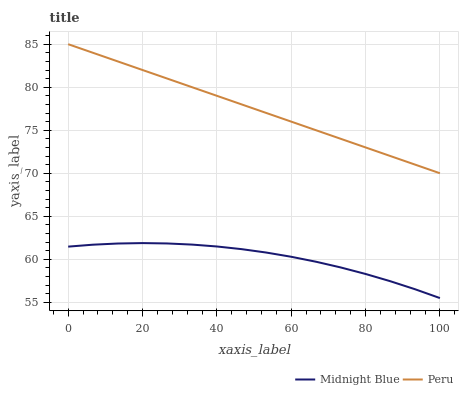Does Midnight Blue have the minimum area under the curve?
Answer yes or no. Yes. Does Peru have the maximum area under the curve?
Answer yes or no. Yes. Does Peru have the minimum area under the curve?
Answer yes or no. No. Is Peru the smoothest?
Answer yes or no. Yes. Is Midnight Blue the roughest?
Answer yes or no. Yes. Is Peru the roughest?
Answer yes or no. No. Does Midnight Blue have the lowest value?
Answer yes or no. Yes. Does Peru have the lowest value?
Answer yes or no. No. Does Peru have the highest value?
Answer yes or no. Yes. Is Midnight Blue less than Peru?
Answer yes or no. Yes. Is Peru greater than Midnight Blue?
Answer yes or no. Yes. Does Midnight Blue intersect Peru?
Answer yes or no. No. 